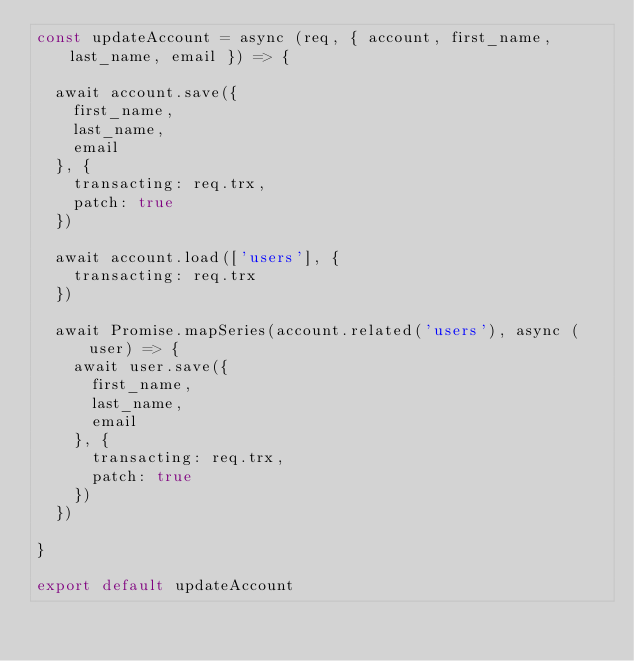Convert code to text. <code><loc_0><loc_0><loc_500><loc_500><_JavaScript_>const updateAccount = async (req, { account, first_name, last_name, email }) => {

  await account.save({
    first_name,
    last_name,
    email
  }, {
    transacting: req.trx,
    patch: true
  })

  await account.load(['users'], {
    transacting: req.trx
  })

  await Promise.mapSeries(account.related('users'), async (user) => {
    await user.save({
      first_name,
      last_name,
      email
    }, {
      transacting: req.trx,
      patch: true
    })
  })

}

export default updateAccount
</code> 